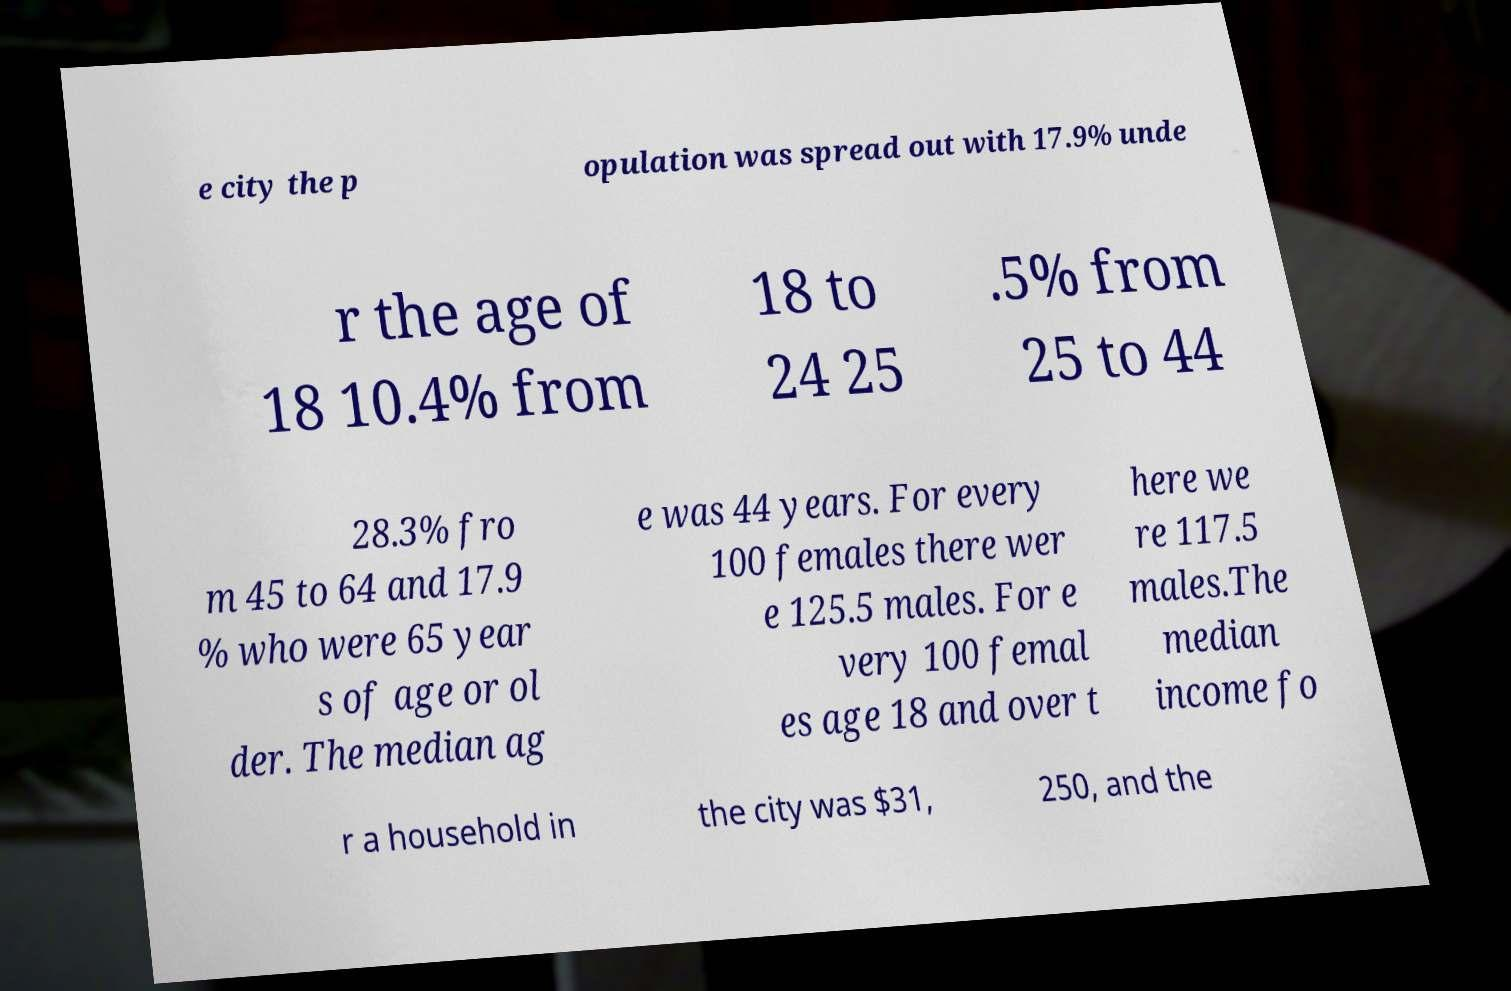Could you extract and type out the text from this image? e city the p opulation was spread out with 17.9% unde r the age of 18 10.4% from 18 to 24 25 .5% from 25 to 44 28.3% fro m 45 to 64 and 17.9 % who were 65 year s of age or ol der. The median ag e was 44 years. For every 100 females there wer e 125.5 males. For e very 100 femal es age 18 and over t here we re 117.5 males.The median income fo r a household in the city was $31, 250, and the 